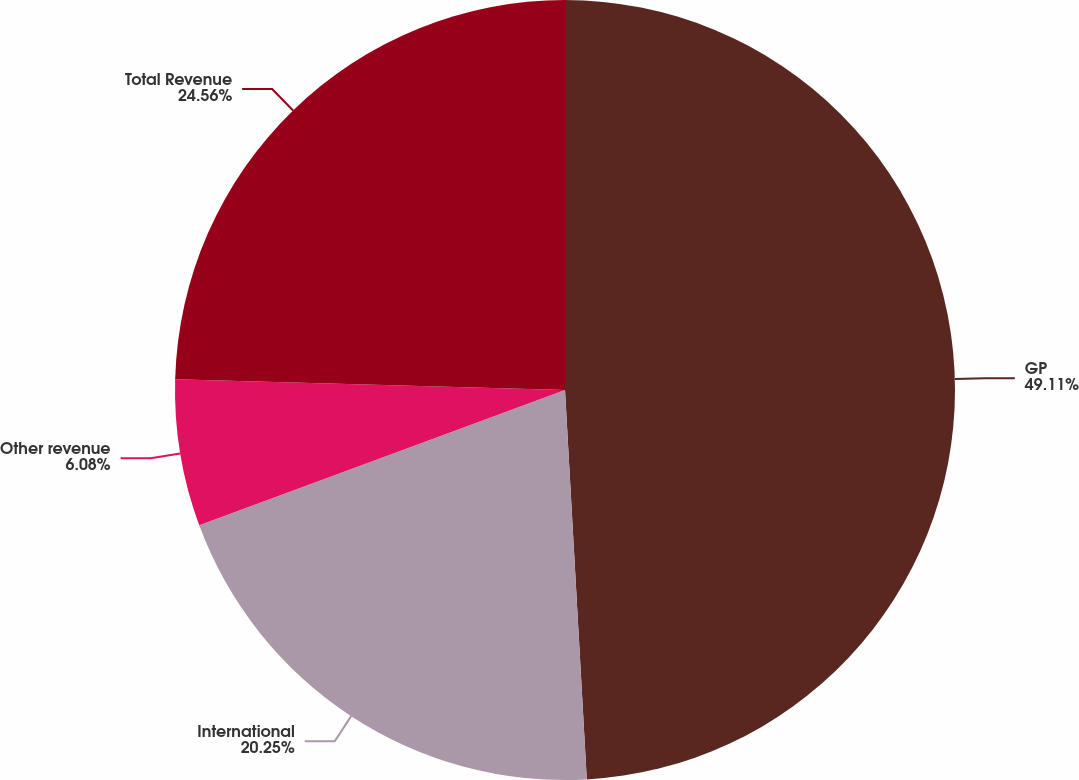<chart> <loc_0><loc_0><loc_500><loc_500><pie_chart><fcel>GP<fcel>International<fcel>Other revenue<fcel>Total Revenue<nl><fcel>49.11%<fcel>20.25%<fcel>6.08%<fcel>24.56%<nl></chart> 